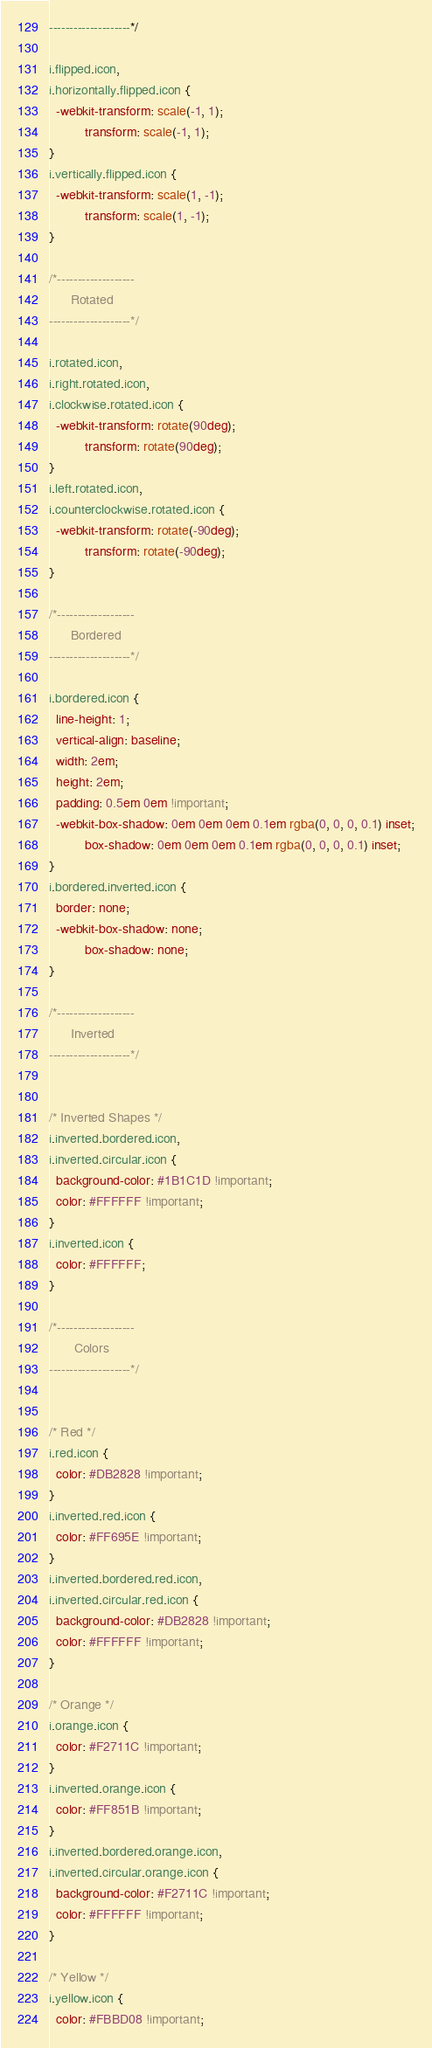Convert code to text. <code><loc_0><loc_0><loc_500><loc_500><_CSS_>--------------------*/

i.flipped.icon,
i.horizontally.flipped.icon {
  -webkit-transform: scale(-1, 1);
          transform: scale(-1, 1);
}
i.vertically.flipped.icon {
  -webkit-transform: scale(1, -1);
          transform: scale(1, -1);
}

/*-------------------
      Rotated
--------------------*/

i.rotated.icon,
i.right.rotated.icon,
i.clockwise.rotated.icon {
  -webkit-transform: rotate(90deg);
          transform: rotate(90deg);
}
i.left.rotated.icon,
i.counterclockwise.rotated.icon {
  -webkit-transform: rotate(-90deg);
          transform: rotate(-90deg);
}

/*-------------------
      Bordered
--------------------*/

i.bordered.icon {
  line-height: 1;
  vertical-align: baseline;
  width: 2em;
  height: 2em;
  padding: 0.5em 0em !important;
  -webkit-box-shadow: 0em 0em 0em 0.1em rgba(0, 0, 0, 0.1) inset;
          box-shadow: 0em 0em 0em 0.1em rgba(0, 0, 0, 0.1) inset;
}
i.bordered.inverted.icon {
  border: none;
  -webkit-box-shadow: none;
          box-shadow: none;
}

/*-------------------
      Inverted
--------------------*/


/* Inverted Shapes */
i.inverted.bordered.icon,
i.inverted.circular.icon {
  background-color: #1B1C1D !important;
  color: #FFFFFF !important;
}
i.inverted.icon {
  color: #FFFFFF;
}

/*-------------------
       Colors
--------------------*/


/* Red */
i.red.icon {
  color: #DB2828 !important;
}
i.inverted.red.icon {
  color: #FF695E !important;
}
i.inverted.bordered.red.icon,
i.inverted.circular.red.icon {
  background-color: #DB2828 !important;
  color: #FFFFFF !important;
}

/* Orange */
i.orange.icon {
  color: #F2711C !important;
}
i.inverted.orange.icon {
  color: #FF851B !important;
}
i.inverted.bordered.orange.icon,
i.inverted.circular.orange.icon {
  background-color: #F2711C !important;
  color: #FFFFFF !important;
}

/* Yellow */
i.yellow.icon {
  color: #FBBD08 !important;</code> 